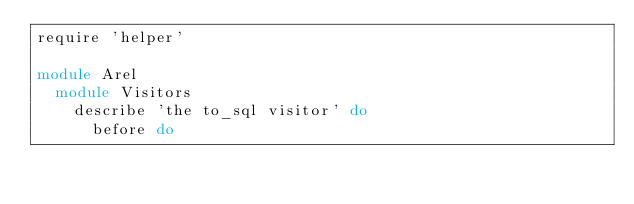<code> <loc_0><loc_0><loc_500><loc_500><_Ruby_>require 'helper'

module Arel
  module Visitors
    describe 'the to_sql visitor' do
      before do</code> 